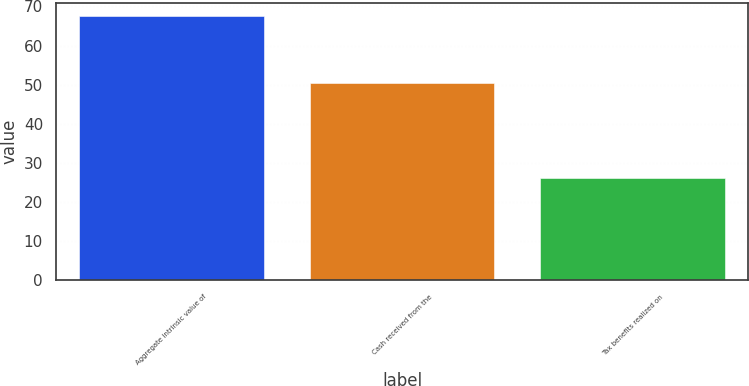<chart> <loc_0><loc_0><loc_500><loc_500><bar_chart><fcel>Aggregate intrinsic value of<fcel>Cash received from the<fcel>Tax benefits realized on<nl><fcel>67.6<fcel>50.5<fcel>26.1<nl></chart> 